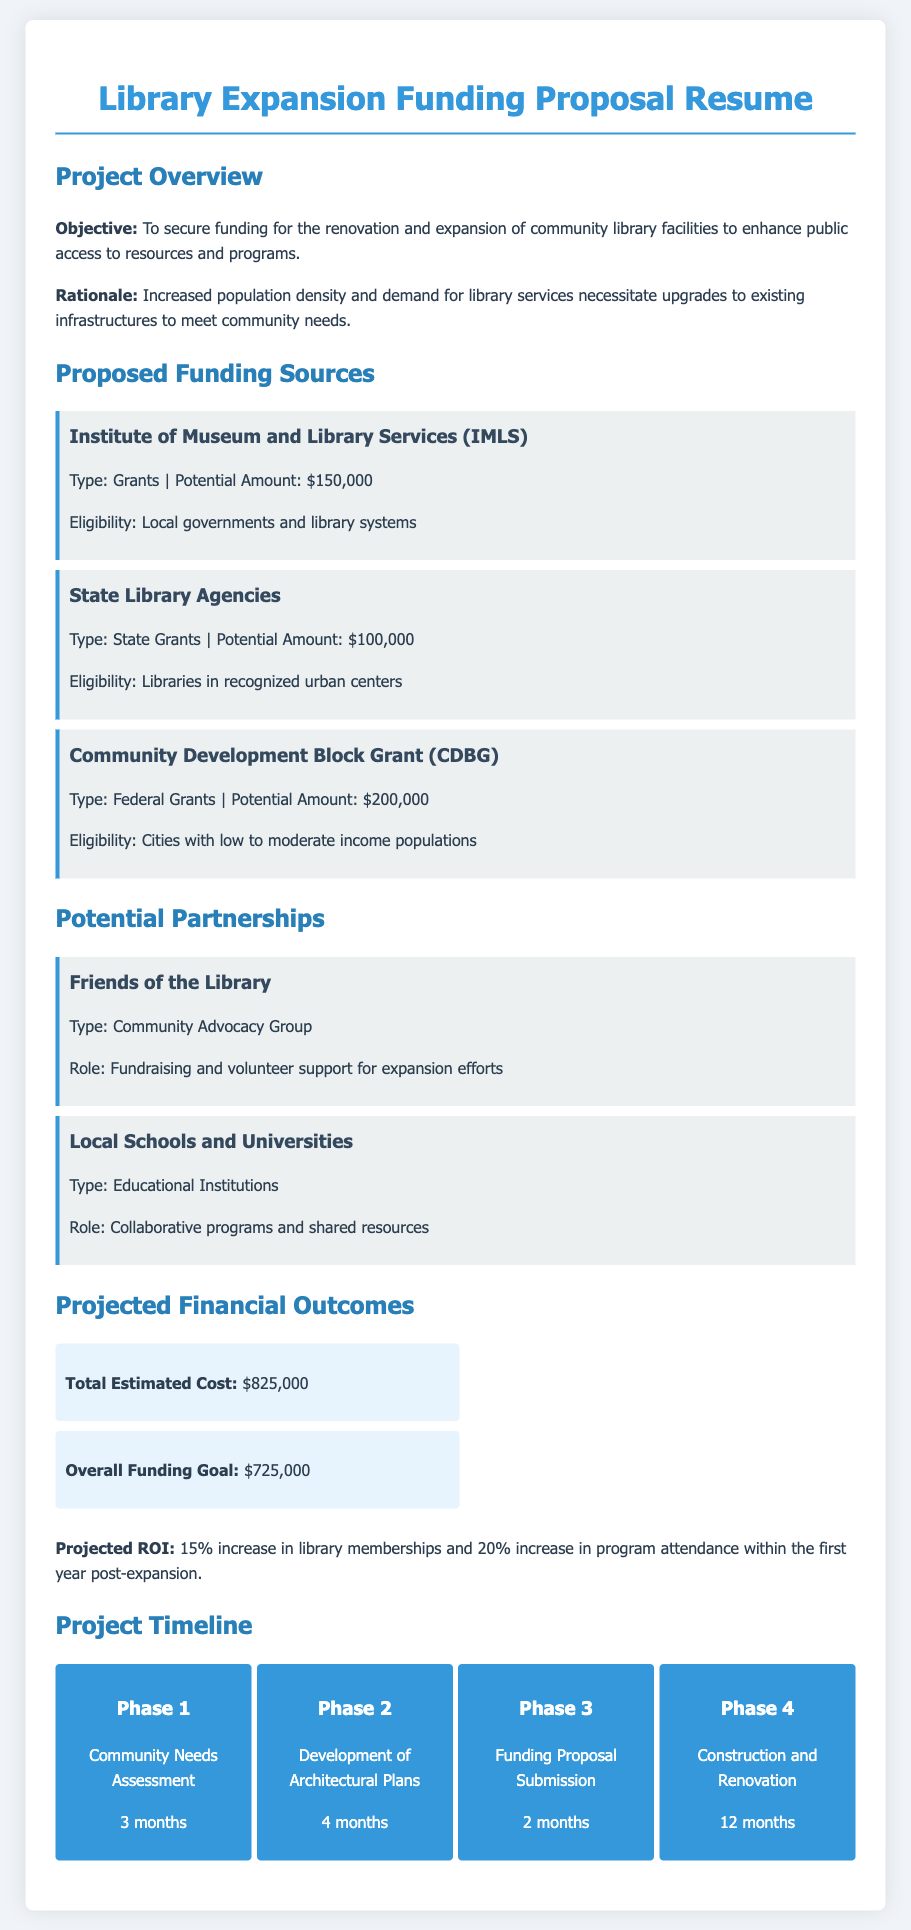What is the total estimated cost of the library expansion? The total estimated cost is stated in the projected financial outcomes section of the document as $825,000.
Answer: $825,000 What is the funding goal for the library expansion? The overall funding goal can be found in the projected financial outcomes section, which is $725,000.
Answer: $725,000 What organization is proposed as a funding source that offers $150,000? The proposed funding source that offers $150,000 is the Institute of Museum and Library Services (IMLS).
Answer: Institute of Museum and Library Services (IMLS) How many phases are there in the project timeline? The number of phases can be counted in the project timeline section, which lists four distinct phases.
Answer: 4 What is one role of the "Friends of the Library" partnership? The role of the "Friends of the Library" partnership is specified as fundraising and volunteer support for expansion efforts.
Answer: Fundraising and volunteer support What is the expected increase in library memberships post-expansion? The document states that the projected ROI includes a 15% increase in library memberships within the first year post-expansion.
Answer: 15% What is the estimated amount from Community Development Block Grant? The document indicates that the potential amount from the Community Development Block Grant (CDBG) is $200,000.
Answer: $200,000 What is the time frame for the community needs assessment phase? The time frame for the community needs assessment phase is specified as 3 months.
Answer: 3 months What is the eligibility requirement for State Library Agencies funding? The eligibility requirement for State Library Agencies funding is that it must be for libraries in recognized urban centers.
Answer: Libraries in recognized urban centers 